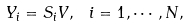<formula> <loc_0><loc_0><loc_500><loc_500>Y _ { i } = S _ { i } V , \text { } i = 1 , \cdots , N ,</formula> 